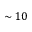<formula> <loc_0><loc_0><loc_500><loc_500>\sim 1 0</formula> 